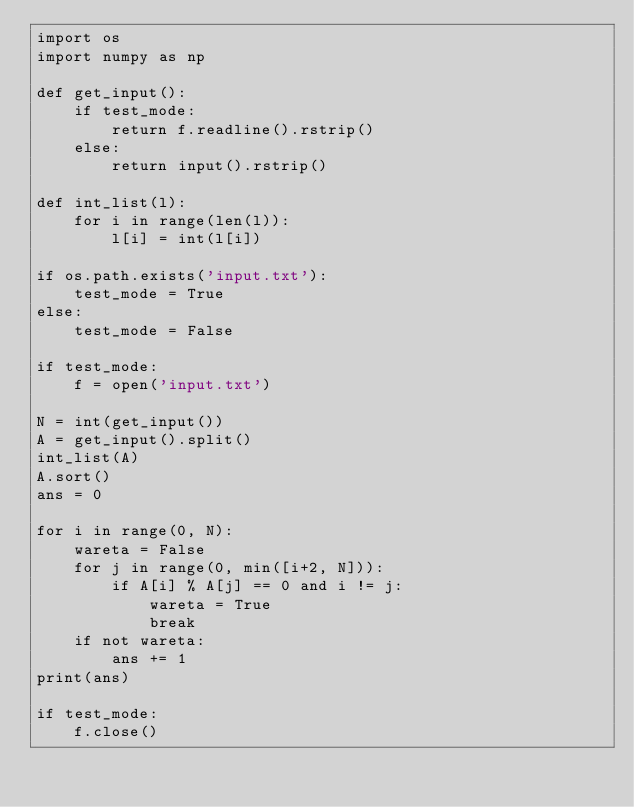<code> <loc_0><loc_0><loc_500><loc_500><_Python_>import os
import numpy as np

def get_input():
    if test_mode:
        return f.readline().rstrip()
    else:
        return input().rstrip()

def int_list(l):
    for i in range(len(l)):
        l[i] = int(l[i])
        
if os.path.exists('input.txt'):
    test_mode = True
else:
    test_mode = False

if test_mode:
    f = open('input.txt')
    
N = int(get_input())
A = get_input().split()
int_list(A)
A.sort()
ans = 0

for i in range(0, N):
    wareta = False
    for j in range(0, min([i+2, N])):
        if A[i] % A[j] == 0 and i != j:
            wareta = True
            break
    if not wareta:
        ans += 1
print(ans)

if test_mode:
    f.close()</code> 